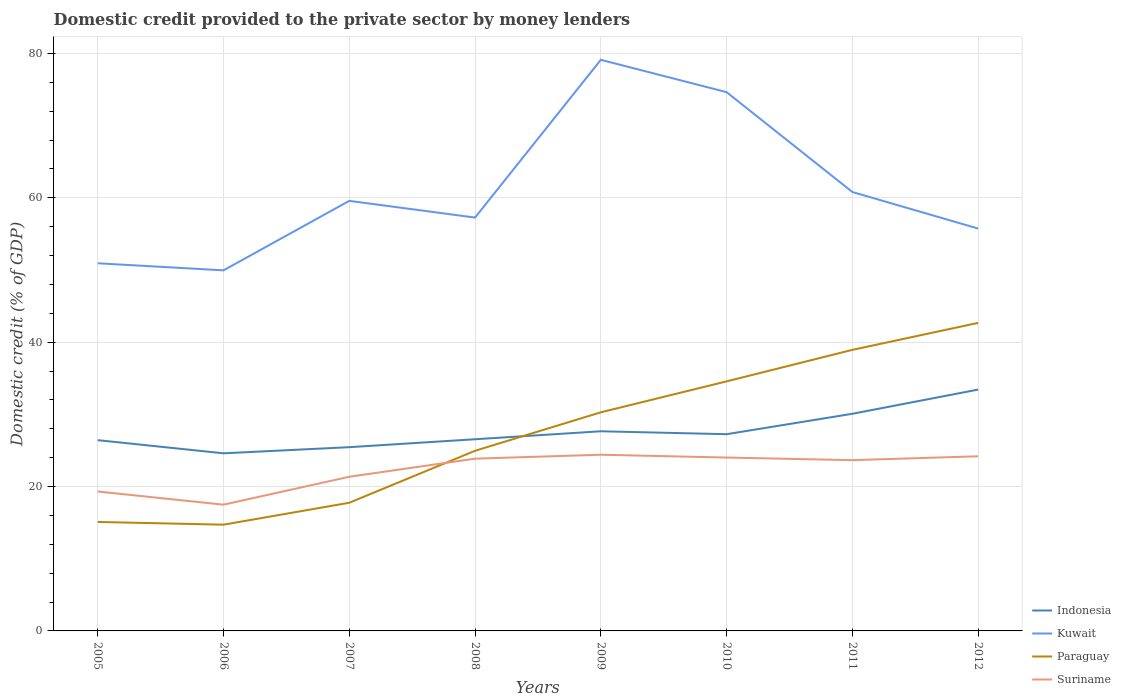How many different coloured lines are there?
Keep it short and to the point. 4. Does the line corresponding to Indonesia intersect with the line corresponding to Paraguay?
Ensure brevity in your answer.  Yes. Is the number of lines equal to the number of legend labels?
Ensure brevity in your answer.  Yes. Across all years, what is the maximum domestic credit provided to the private sector by money lenders in Indonesia?
Your response must be concise. 24.61. In which year was the domestic credit provided to the private sector by money lenders in Paraguay maximum?
Give a very brief answer. 2006. What is the total domestic credit provided to the private sector by money lenders in Suriname in the graph?
Keep it short and to the point. -2.84. What is the difference between the highest and the second highest domestic credit provided to the private sector by money lenders in Paraguay?
Ensure brevity in your answer.  27.96. What is the difference between the highest and the lowest domestic credit provided to the private sector by money lenders in Paraguay?
Your answer should be very brief. 4. Is the domestic credit provided to the private sector by money lenders in Kuwait strictly greater than the domestic credit provided to the private sector by money lenders in Paraguay over the years?
Provide a short and direct response. No. How many lines are there?
Make the answer very short. 4. Does the graph contain any zero values?
Your answer should be compact. No. How many legend labels are there?
Your answer should be compact. 4. What is the title of the graph?
Keep it short and to the point. Domestic credit provided to the private sector by money lenders. What is the label or title of the Y-axis?
Provide a succinct answer. Domestic credit (% of GDP). What is the Domestic credit (% of GDP) of Indonesia in 2005?
Your answer should be very brief. 26.43. What is the Domestic credit (% of GDP) of Kuwait in 2005?
Your answer should be very brief. 50.93. What is the Domestic credit (% of GDP) in Paraguay in 2005?
Make the answer very short. 15.1. What is the Domestic credit (% of GDP) of Suriname in 2005?
Provide a succinct answer. 19.32. What is the Domestic credit (% of GDP) in Indonesia in 2006?
Your answer should be very brief. 24.61. What is the Domestic credit (% of GDP) of Kuwait in 2006?
Ensure brevity in your answer.  49.95. What is the Domestic credit (% of GDP) of Paraguay in 2006?
Your answer should be compact. 14.72. What is the Domestic credit (% of GDP) of Suriname in 2006?
Your answer should be compact. 17.49. What is the Domestic credit (% of GDP) in Indonesia in 2007?
Your answer should be very brief. 25.46. What is the Domestic credit (% of GDP) of Kuwait in 2007?
Give a very brief answer. 59.58. What is the Domestic credit (% of GDP) of Paraguay in 2007?
Offer a very short reply. 17.76. What is the Domestic credit (% of GDP) in Suriname in 2007?
Make the answer very short. 21.36. What is the Domestic credit (% of GDP) of Indonesia in 2008?
Your answer should be compact. 26.55. What is the Domestic credit (% of GDP) in Kuwait in 2008?
Your response must be concise. 57.26. What is the Domestic credit (% of GDP) of Paraguay in 2008?
Make the answer very short. 24.96. What is the Domestic credit (% of GDP) in Suriname in 2008?
Your answer should be very brief. 23.86. What is the Domestic credit (% of GDP) in Indonesia in 2009?
Give a very brief answer. 27.66. What is the Domestic credit (% of GDP) of Kuwait in 2009?
Give a very brief answer. 79.12. What is the Domestic credit (% of GDP) of Paraguay in 2009?
Provide a short and direct response. 30.29. What is the Domestic credit (% of GDP) of Suriname in 2009?
Give a very brief answer. 24.41. What is the Domestic credit (% of GDP) of Indonesia in 2010?
Provide a succinct answer. 27.25. What is the Domestic credit (% of GDP) in Kuwait in 2010?
Offer a terse response. 74.64. What is the Domestic credit (% of GDP) in Paraguay in 2010?
Keep it short and to the point. 34.57. What is the Domestic credit (% of GDP) of Suriname in 2010?
Give a very brief answer. 24.02. What is the Domestic credit (% of GDP) of Indonesia in 2011?
Provide a succinct answer. 30.08. What is the Domestic credit (% of GDP) of Kuwait in 2011?
Provide a succinct answer. 60.81. What is the Domestic credit (% of GDP) of Paraguay in 2011?
Keep it short and to the point. 38.94. What is the Domestic credit (% of GDP) in Suriname in 2011?
Provide a short and direct response. 23.66. What is the Domestic credit (% of GDP) in Indonesia in 2012?
Your response must be concise. 33.43. What is the Domestic credit (% of GDP) of Kuwait in 2012?
Give a very brief answer. 55.74. What is the Domestic credit (% of GDP) in Paraguay in 2012?
Your answer should be compact. 42.68. What is the Domestic credit (% of GDP) of Suriname in 2012?
Offer a terse response. 24.19. Across all years, what is the maximum Domestic credit (% of GDP) in Indonesia?
Your response must be concise. 33.43. Across all years, what is the maximum Domestic credit (% of GDP) in Kuwait?
Provide a short and direct response. 79.12. Across all years, what is the maximum Domestic credit (% of GDP) of Paraguay?
Your response must be concise. 42.68. Across all years, what is the maximum Domestic credit (% of GDP) of Suriname?
Provide a succinct answer. 24.41. Across all years, what is the minimum Domestic credit (% of GDP) of Indonesia?
Your response must be concise. 24.61. Across all years, what is the minimum Domestic credit (% of GDP) in Kuwait?
Your response must be concise. 49.95. Across all years, what is the minimum Domestic credit (% of GDP) of Paraguay?
Provide a succinct answer. 14.72. Across all years, what is the minimum Domestic credit (% of GDP) of Suriname?
Offer a very short reply. 17.49. What is the total Domestic credit (% of GDP) of Indonesia in the graph?
Give a very brief answer. 221.47. What is the total Domestic credit (% of GDP) in Kuwait in the graph?
Your answer should be compact. 488.04. What is the total Domestic credit (% of GDP) in Paraguay in the graph?
Provide a short and direct response. 219. What is the total Domestic credit (% of GDP) in Suriname in the graph?
Ensure brevity in your answer.  178.31. What is the difference between the Domestic credit (% of GDP) in Indonesia in 2005 and that in 2006?
Your answer should be very brief. 1.82. What is the difference between the Domestic credit (% of GDP) in Kuwait in 2005 and that in 2006?
Offer a terse response. 0.98. What is the difference between the Domestic credit (% of GDP) in Paraguay in 2005 and that in 2006?
Your answer should be very brief. 0.38. What is the difference between the Domestic credit (% of GDP) of Suriname in 2005 and that in 2006?
Provide a succinct answer. 1.83. What is the difference between the Domestic credit (% of GDP) of Indonesia in 2005 and that in 2007?
Offer a very short reply. 0.97. What is the difference between the Domestic credit (% of GDP) of Kuwait in 2005 and that in 2007?
Provide a succinct answer. -8.65. What is the difference between the Domestic credit (% of GDP) in Paraguay in 2005 and that in 2007?
Make the answer very short. -2.66. What is the difference between the Domestic credit (% of GDP) of Suriname in 2005 and that in 2007?
Give a very brief answer. -2.04. What is the difference between the Domestic credit (% of GDP) in Indonesia in 2005 and that in 2008?
Keep it short and to the point. -0.13. What is the difference between the Domestic credit (% of GDP) of Kuwait in 2005 and that in 2008?
Give a very brief answer. -6.33. What is the difference between the Domestic credit (% of GDP) of Paraguay in 2005 and that in 2008?
Provide a succinct answer. -9.86. What is the difference between the Domestic credit (% of GDP) of Suriname in 2005 and that in 2008?
Provide a succinct answer. -4.55. What is the difference between the Domestic credit (% of GDP) of Indonesia in 2005 and that in 2009?
Your answer should be very brief. -1.23. What is the difference between the Domestic credit (% of GDP) of Kuwait in 2005 and that in 2009?
Provide a succinct answer. -28.19. What is the difference between the Domestic credit (% of GDP) in Paraguay in 2005 and that in 2009?
Your answer should be compact. -15.19. What is the difference between the Domestic credit (% of GDP) of Suriname in 2005 and that in 2009?
Offer a terse response. -5.09. What is the difference between the Domestic credit (% of GDP) in Indonesia in 2005 and that in 2010?
Give a very brief answer. -0.83. What is the difference between the Domestic credit (% of GDP) in Kuwait in 2005 and that in 2010?
Provide a succinct answer. -23.71. What is the difference between the Domestic credit (% of GDP) of Paraguay in 2005 and that in 2010?
Your answer should be very brief. -19.48. What is the difference between the Domestic credit (% of GDP) of Suriname in 2005 and that in 2010?
Offer a very short reply. -4.7. What is the difference between the Domestic credit (% of GDP) in Indonesia in 2005 and that in 2011?
Make the answer very short. -3.65. What is the difference between the Domestic credit (% of GDP) in Kuwait in 2005 and that in 2011?
Your response must be concise. -9.87. What is the difference between the Domestic credit (% of GDP) of Paraguay in 2005 and that in 2011?
Your answer should be compact. -23.84. What is the difference between the Domestic credit (% of GDP) of Suriname in 2005 and that in 2011?
Offer a terse response. -4.34. What is the difference between the Domestic credit (% of GDP) of Indonesia in 2005 and that in 2012?
Offer a very short reply. -7.01. What is the difference between the Domestic credit (% of GDP) in Kuwait in 2005 and that in 2012?
Give a very brief answer. -4.81. What is the difference between the Domestic credit (% of GDP) in Paraguay in 2005 and that in 2012?
Provide a succinct answer. -27.58. What is the difference between the Domestic credit (% of GDP) of Suriname in 2005 and that in 2012?
Keep it short and to the point. -4.88. What is the difference between the Domestic credit (% of GDP) of Indonesia in 2006 and that in 2007?
Ensure brevity in your answer.  -0.85. What is the difference between the Domestic credit (% of GDP) in Kuwait in 2006 and that in 2007?
Make the answer very short. -9.63. What is the difference between the Domestic credit (% of GDP) in Paraguay in 2006 and that in 2007?
Make the answer very short. -3.04. What is the difference between the Domestic credit (% of GDP) of Suriname in 2006 and that in 2007?
Provide a succinct answer. -3.87. What is the difference between the Domestic credit (% of GDP) in Indonesia in 2006 and that in 2008?
Keep it short and to the point. -1.95. What is the difference between the Domestic credit (% of GDP) in Kuwait in 2006 and that in 2008?
Offer a terse response. -7.31. What is the difference between the Domestic credit (% of GDP) of Paraguay in 2006 and that in 2008?
Keep it short and to the point. -10.24. What is the difference between the Domestic credit (% of GDP) of Suriname in 2006 and that in 2008?
Ensure brevity in your answer.  -6.38. What is the difference between the Domestic credit (% of GDP) of Indonesia in 2006 and that in 2009?
Ensure brevity in your answer.  -3.05. What is the difference between the Domestic credit (% of GDP) in Kuwait in 2006 and that in 2009?
Your answer should be compact. -29.17. What is the difference between the Domestic credit (% of GDP) of Paraguay in 2006 and that in 2009?
Your response must be concise. -15.57. What is the difference between the Domestic credit (% of GDP) of Suriname in 2006 and that in 2009?
Make the answer very short. -6.92. What is the difference between the Domestic credit (% of GDP) in Indonesia in 2006 and that in 2010?
Your answer should be compact. -2.65. What is the difference between the Domestic credit (% of GDP) of Kuwait in 2006 and that in 2010?
Ensure brevity in your answer.  -24.69. What is the difference between the Domestic credit (% of GDP) of Paraguay in 2006 and that in 2010?
Keep it short and to the point. -19.85. What is the difference between the Domestic credit (% of GDP) of Suriname in 2006 and that in 2010?
Give a very brief answer. -6.53. What is the difference between the Domestic credit (% of GDP) in Indonesia in 2006 and that in 2011?
Ensure brevity in your answer.  -5.48. What is the difference between the Domestic credit (% of GDP) of Kuwait in 2006 and that in 2011?
Your response must be concise. -10.85. What is the difference between the Domestic credit (% of GDP) of Paraguay in 2006 and that in 2011?
Your response must be concise. -24.22. What is the difference between the Domestic credit (% of GDP) of Suriname in 2006 and that in 2011?
Provide a succinct answer. -6.17. What is the difference between the Domestic credit (% of GDP) in Indonesia in 2006 and that in 2012?
Provide a short and direct response. -8.83. What is the difference between the Domestic credit (% of GDP) of Kuwait in 2006 and that in 2012?
Offer a very short reply. -5.79. What is the difference between the Domestic credit (% of GDP) in Paraguay in 2006 and that in 2012?
Ensure brevity in your answer.  -27.96. What is the difference between the Domestic credit (% of GDP) of Suriname in 2006 and that in 2012?
Provide a short and direct response. -6.71. What is the difference between the Domestic credit (% of GDP) in Indonesia in 2007 and that in 2008?
Offer a terse response. -1.1. What is the difference between the Domestic credit (% of GDP) in Kuwait in 2007 and that in 2008?
Provide a short and direct response. 2.31. What is the difference between the Domestic credit (% of GDP) in Paraguay in 2007 and that in 2008?
Your response must be concise. -7.2. What is the difference between the Domestic credit (% of GDP) of Suriname in 2007 and that in 2008?
Make the answer very short. -2.51. What is the difference between the Domestic credit (% of GDP) of Indonesia in 2007 and that in 2009?
Make the answer very short. -2.2. What is the difference between the Domestic credit (% of GDP) of Kuwait in 2007 and that in 2009?
Your answer should be compact. -19.54. What is the difference between the Domestic credit (% of GDP) of Paraguay in 2007 and that in 2009?
Offer a very short reply. -12.53. What is the difference between the Domestic credit (% of GDP) of Suriname in 2007 and that in 2009?
Your answer should be compact. -3.05. What is the difference between the Domestic credit (% of GDP) of Indonesia in 2007 and that in 2010?
Give a very brief answer. -1.8. What is the difference between the Domestic credit (% of GDP) of Kuwait in 2007 and that in 2010?
Offer a terse response. -15.06. What is the difference between the Domestic credit (% of GDP) of Paraguay in 2007 and that in 2010?
Your answer should be compact. -16.82. What is the difference between the Domestic credit (% of GDP) of Suriname in 2007 and that in 2010?
Provide a short and direct response. -2.66. What is the difference between the Domestic credit (% of GDP) in Indonesia in 2007 and that in 2011?
Give a very brief answer. -4.63. What is the difference between the Domestic credit (% of GDP) in Kuwait in 2007 and that in 2011?
Your response must be concise. -1.23. What is the difference between the Domestic credit (% of GDP) in Paraguay in 2007 and that in 2011?
Give a very brief answer. -21.18. What is the difference between the Domestic credit (% of GDP) in Suriname in 2007 and that in 2011?
Offer a terse response. -2.3. What is the difference between the Domestic credit (% of GDP) of Indonesia in 2007 and that in 2012?
Keep it short and to the point. -7.98. What is the difference between the Domestic credit (% of GDP) in Kuwait in 2007 and that in 2012?
Your response must be concise. 3.84. What is the difference between the Domestic credit (% of GDP) in Paraguay in 2007 and that in 2012?
Give a very brief answer. -24.92. What is the difference between the Domestic credit (% of GDP) in Suriname in 2007 and that in 2012?
Make the answer very short. -2.84. What is the difference between the Domestic credit (% of GDP) in Indonesia in 2008 and that in 2009?
Give a very brief answer. -1.11. What is the difference between the Domestic credit (% of GDP) of Kuwait in 2008 and that in 2009?
Give a very brief answer. -21.85. What is the difference between the Domestic credit (% of GDP) in Paraguay in 2008 and that in 2009?
Your response must be concise. -5.33. What is the difference between the Domestic credit (% of GDP) of Suriname in 2008 and that in 2009?
Offer a terse response. -0.54. What is the difference between the Domestic credit (% of GDP) of Indonesia in 2008 and that in 2010?
Provide a short and direct response. -0.7. What is the difference between the Domestic credit (% of GDP) in Kuwait in 2008 and that in 2010?
Your answer should be very brief. -17.37. What is the difference between the Domestic credit (% of GDP) of Paraguay in 2008 and that in 2010?
Your answer should be very brief. -9.62. What is the difference between the Domestic credit (% of GDP) of Suriname in 2008 and that in 2010?
Your response must be concise. -0.15. What is the difference between the Domestic credit (% of GDP) in Indonesia in 2008 and that in 2011?
Your answer should be very brief. -3.53. What is the difference between the Domestic credit (% of GDP) in Kuwait in 2008 and that in 2011?
Offer a terse response. -3.54. What is the difference between the Domestic credit (% of GDP) of Paraguay in 2008 and that in 2011?
Your answer should be compact. -13.98. What is the difference between the Domestic credit (% of GDP) in Suriname in 2008 and that in 2011?
Give a very brief answer. 0.21. What is the difference between the Domestic credit (% of GDP) of Indonesia in 2008 and that in 2012?
Your response must be concise. -6.88. What is the difference between the Domestic credit (% of GDP) in Kuwait in 2008 and that in 2012?
Keep it short and to the point. 1.52. What is the difference between the Domestic credit (% of GDP) of Paraguay in 2008 and that in 2012?
Your response must be concise. -17.72. What is the difference between the Domestic credit (% of GDP) in Suriname in 2008 and that in 2012?
Your response must be concise. -0.33. What is the difference between the Domestic credit (% of GDP) in Indonesia in 2009 and that in 2010?
Your answer should be compact. 0.41. What is the difference between the Domestic credit (% of GDP) of Kuwait in 2009 and that in 2010?
Your response must be concise. 4.48. What is the difference between the Domestic credit (% of GDP) in Paraguay in 2009 and that in 2010?
Your answer should be very brief. -4.29. What is the difference between the Domestic credit (% of GDP) of Suriname in 2009 and that in 2010?
Give a very brief answer. 0.39. What is the difference between the Domestic credit (% of GDP) in Indonesia in 2009 and that in 2011?
Your answer should be very brief. -2.42. What is the difference between the Domestic credit (% of GDP) in Kuwait in 2009 and that in 2011?
Offer a very short reply. 18.31. What is the difference between the Domestic credit (% of GDP) in Paraguay in 2009 and that in 2011?
Keep it short and to the point. -8.65. What is the difference between the Domestic credit (% of GDP) in Suriname in 2009 and that in 2011?
Provide a short and direct response. 0.75. What is the difference between the Domestic credit (% of GDP) in Indonesia in 2009 and that in 2012?
Offer a very short reply. -5.78. What is the difference between the Domestic credit (% of GDP) in Kuwait in 2009 and that in 2012?
Provide a short and direct response. 23.38. What is the difference between the Domestic credit (% of GDP) in Paraguay in 2009 and that in 2012?
Your response must be concise. -12.39. What is the difference between the Domestic credit (% of GDP) in Suriname in 2009 and that in 2012?
Provide a short and direct response. 0.21. What is the difference between the Domestic credit (% of GDP) of Indonesia in 2010 and that in 2011?
Provide a succinct answer. -2.83. What is the difference between the Domestic credit (% of GDP) in Kuwait in 2010 and that in 2011?
Provide a succinct answer. 13.83. What is the difference between the Domestic credit (% of GDP) of Paraguay in 2010 and that in 2011?
Offer a terse response. -4.37. What is the difference between the Domestic credit (% of GDP) in Suriname in 2010 and that in 2011?
Offer a terse response. 0.36. What is the difference between the Domestic credit (% of GDP) of Indonesia in 2010 and that in 2012?
Offer a terse response. -6.18. What is the difference between the Domestic credit (% of GDP) of Kuwait in 2010 and that in 2012?
Your answer should be very brief. 18.9. What is the difference between the Domestic credit (% of GDP) of Paraguay in 2010 and that in 2012?
Offer a very short reply. -8.1. What is the difference between the Domestic credit (% of GDP) of Suriname in 2010 and that in 2012?
Keep it short and to the point. -0.18. What is the difference between the Domestic credit (% of GDP) in Indonesia in 2011 and that in 2012?
Provide a short and direct response. -3.35. What is the difference between the Domestic credit (% of GDP) of Kuwait in 2011 and that in 2012?
Provide a short and direct response. 5.06. What is the difference between the Domestic credit (% of GDP) in Paraguay in 2011 and that in 2012?
Your response must be concise. -3.74. What is the difference between the Domestic credit (% of GDP) of Suriname in 2011 and that in 2012?
Ensure brevity in your answer.  -0.54. What is the difference between the Domestic credit (% of GDP) in Indonesia in 2005 and the Domestic credit (% of GDP) in Kuwait in 2006?
Your response must be concise. -23.53. What is the difference between the Domestic credit (% of GDP) of Indonesia in 2005 and the Domestic credit (% of GDP) of Paraguay in 2006?
Keep it short and to the point. 11.71. What is the difference between the Domestic credit (% of GDP) in Indonesia in 2005 and the Domestic credit (% of GDP) in Suriname in 2006?
Your response must be concise. 8.94. What is the difference between the Domestic credit (% of GDP) of Kuwait in 2005 and the Domestic credit (% of GDP) of Paraguay in 2006?
Your answer should be very brief. 36.21. What is the difference between the Domestic credit (% of GDP) in Kuwait in 2005 and the Domestic credit (% of GDP) in Suriname in 2006?
Give a very brief answer. 33.44. What is the difference between the Domestic credit (% of GDP) in Paraguay in 2005 and the Domestic credit (% of GDP) in Suriname in 2006?
Provide a short and direct response. -2.39. What is the difference between the Domestic credit (% of GDP) in Indonesia in 2005 and the Domestic credit (% of GDP) in Kuwait in 2007?
Your answer should be very brief. -33.15. What is the difference between the Domestic credit (% of GDP) in Indonesia in 2005 and the Domestic credit (% of GDP) in Paraguay in 2007?
Your response must be concise. 8.67. What is the difference between the Domestic credit (% of GDP) in Indonesia in 2005 and the Domestic credit (% of GDP) in Suriname in 2007?
Keep it short and to the point. 5.07. What is the difference between the Domestic credit (% of GDP) of Kuwait in 2005 and the Domestic credit (% of GDP) of Paraguay in 2007?
Offer a very short reply. 33.18. What is the difference between the Domestic credit (% of GDP) of Kuwait in 2005 and the Domestic credit (% of GDP) of Suriname in 2007?
Give a very brief answer. 29.57. What is the difference between the Domestic credit (% of GDP) in Paraguay in 2005 and the Domestic credit (% of GDP) in Suriname in 2007?
Keep it short and to the point. -6.26. What is the difference between the Domestic credit (% of GDP) of Indonesia in 2005 and the Domestic credit (% of GDP) of Kuwait in 2008?
Your answer should be very brief. -30.84. What is the difference between the Domestic credit (% of GDP) in Indonesia in 2005 and the Domestic credit (% of GDP) in Paraguay in 2008?
Offer a very short reply. 1.47. What is the difference between the Domestic credit (% of GDP) of Indonesia in 2005 and the Domestic credit (% of GDP) of Suriname in 2008?
Make the answer very short. 2.56. What is the difference between the Domestic credit (% of GDP) in Kuwait in 2005 and the Domestic credit (% of GDP) in Paraguay in 2008?
Provide a succinct answer. 25.98. What is the difference between the Domestic credit (% of GDP) in Kuwait in 2005 and the Domestic credit (% of GDP) in Suriname in 2008?
Ensure brevity in your answer.  27.07. What is the difference between the Domestic credit (% of GDP) in Paraguay in 2005 and the Domestic credit (% of GDP) in Suriname in 2008?
Your answer should be very brief. -8.77. What is the difference between the Domestic credit (% of GDP) of Indonesia in 2005 and the Domestic credit (% of GDP) of Kuwait in 2009?
Offer a terse response. -52.69. What is the difference between the Domestic credit (% of GDP) of Indonesia in 2005 and the Domestic credit (% of GDP) of Paraguay in 2009?
Your answer should be compact. -3.86. What is the difference between the Domestic credit (% of GDP) of Indonesia in 2005 and the Domestic credit (% of GDP) of Suriname in 2009?
Provide a short and direct response. 2.02. What is the difference between the Domestic credit (% of GDP) of Kuwait in 2005 and the Domestic credit (% of GDP) of Paraguay in 2009?
Give a very brief answer. 20.65. What is the difference between the Domestic credit (% of GDP) in Kuwait in 2005 and the Domestic credit (% of GDP) in Suriname in 2009?
Your answer should be very brief. 26.53. What is the difference between the Domestic credit (% of GDP) in Paraguay in 2005 and the Domestic credit (% of GDP) in Suriname in 2009?
Ensure brevity in your answer.  -9.31. What is the difference between the Domestic credit (% of GDP) of Indonesia in 2005 and the Domestic credit (% of GDP) of Kuwait in 2010?
Ensure brevity in your answer.  -48.21. What is the difference between the Domestic credit (% of GDP) of Indonesia in 2005 and the Domestic credit (% of GDP) of Paraguay in 2010?
Make the answer very short. -8.14. What is the difference between the Domestic credit (% of GDP) in Indonesia in 2005 and the Domestic credit (% of GDP) in Suriname in 2010?
Keep it short and to the point. 2.41. What is the difference between the Domestic credit (% of GDP) of Kuwait in 2005 and the Domestic credit (% of GDP) of Paraguay in 2010?
Keep it short and to the point. 16.36. What is the difference between the Domestic credit (% of GDP) in Kuwait in 2005 and the Domestic credit (% of GDP) in Suriname in 2010?
Provide a succinct answer. 26.91. What is the difference between the Domestic credit (% of GDP) in Paraguay in 2005 and the Domestic credit (% of GDP) in Suriname in 2010?
Offer a terse response. -8.92. What is the difference between the Domestic credit (% of GDP) of Indonesia in 2005 and the Domestic credit (% of GDP) of Kuwait in 2011?
Give a very brief answer. -34.38. What is the difference between the Domestic credit (% of GDP) in Indonesia in 2005 and the Domestic credit (% of GDP) in Paraguay in 2011?
Make the answer very short. -12.51. What is the difference between the Domestic credit (% of GDP) of Indonesia in 2005 and the Domestic credit (% of GDP) of Suriname in 2011?
Offer a very short reply. 2.77. What is the difference between the Domestic credit (% of GDP) of Kuwait in 2005 and the Domestic credit (% of GDP) of Paraguay in 2011?
Ensure brevity in your answer.  12. What is the difference between the Domestic credit (% of GDP) of Kuwait in 2005 and the Domestic credit (% of GDP) of Suriname in 2011?
Offer a terse response. 27.28. What is the difference between the Domestic credit (% of GDP) of Paraguay in 2005 and the Domestic credit (% of GDP) of Suriname in 2011?
Offer a very short reply. -8.56. What is the difference between the Domestic credit (% of GDP) of Indonesia in 2005 and the Domestic credit (% of GDP) of Kuwait in 2012?
Keep it short and to the point. -29.32. What is the difference between the Domestic credit (% of GDP) in Indonesia in 2005 and the Domestic credit (% of GDP) in Paraguay in 2012?
Your response must be concise. -16.25. What is the difference between the Domestic credit (% of GDP) of Indonesia in 2005 and the Domestic credit (% of GDP) of Suriname in 2012?
Provide a succinct answer. 2.23. What is the difference between the Domestic credit (% of GDP) of Kuwait in 2005 and the Domestic credit (% of GDP) of Paraguay in 2012?
Give a very brief answer. 8.26. What is the difference between the Domestic credit (% of GDP) in Kuwait in 2005 and the Domestic credit (% of GDP) in Suriname in 2012?
Ensure brevity in your answer.  26.74. What is the difference between the Domestic credit (% of GDP) of Paraguay in 2005 and the Domestic credit (% of GDP) of Suriname in 2012?
Offer a terse response. -9.1. What is the difference between the Domestic credit (% of GDP) of Indonesia in 2006 and the Domestic credit (% of GDP) of Kuwait in 2007?
Make the answer very short. -34.97. What is the difference between the Domestic credit (% of GDP) in Indonesia in 2006 and the Domestic credit (% of GDP) in Paraguay in 2007?
Make the answer very short. 6.85. What is the difference between the Domestic credit (% of GDP) in Indonesia in 2006 and the Domestic credit (% of GDP) in Suriname in 2007?
Offer a very short reply. 3.25. What is the difference between the Domestic credit (% of GDP) of Kuwait in 2006 and the Domestic credit (% of GDP) of Paraguay in 2007?
Your answer should be compact. 32.2. What is the difference between the Domestic credit (% of GDP) in Kuwait in 2006 and the Domestic credit (% of GDP) in Suriname in 2007?
Ensure brevity in your answer.  28.59. What is the difference between the Domestic credit (% of GDP) in Paraguay in 2006 and the Domestic credit (% of GDP) in Suriname in 2007?
Your response must be concise. -6.64. What is the difference between the Domestic credit (% of GDP) of Indonesia in 2006 and the Domestic credit (% of GDP) of Kuwait in 2008?
Your response must be concise. -32.66. What is the difference between the Domestic credit (% of GDP) of Indonesia in 2006 and the Domestic credit (% of GDP) of Paraguay in 2008?
Provide a succinct answer. -0.35. What is the difference between the Domestic credit (% of GDP) in Indonesia in 2006 and the Domestic credit (% of GDP) in Suriname in 2008?
Make the answer very short. 0.74. What is the difference between the Domestic credit (% of GDP) in Kuwait in 2006 and the Domestic credit (% of GDP) in Paraguay in 2008?
Your answer should be compact. 25. What is the difference between the Domestic credit (% of GDP) in Kuwait in 2006 and the Domestic credit (% of GDP) in Suriname in 2008?
Provide a succinct answer. 26.09. What is the difference between the Domestic credit (% of GDP) of Paraguay in 2006 and the Domestic credit (% of GDP) of Suriname in 2008?
Your answer should be compact. -9.15. What is the difference between the Domestic credit (% of GDP) of Indonesia in 2006 and the Domestic credit (% of GDP) of Kuwait in 2009?
Offer a very short reply. -54.51. What is the difference between the Domestic credit (% of GDP) in Indonesia in 2006 and the Domestic credit (% of GDP) in Paraguay in 2009?
Keep it short and to the point. -5.68. What is the difference between the Domestic credit (% of GDP) in Indonesia in 2006 and the Domestic credit (% of GDP) in Suriname in 2009?
Provide a succinct answer. 0.2. What is the difference between the Domestic credit (% of GDP) of Kuwait in 2006 and the Domestic credit (% of GDP) of Paraguay in 2009?
Your response must be concise. 19.67. What is the difference between the Domestic credit (% of GDP) of Kuwait in 2006 and the Domestic credit (% of GDP) of Suriname in 2009?
Keep it short and to the point. 25.55. What is the difference between the Domestic credit (% of GDP) of Paraguay in 2006 and the Domestic credit (% of GDP) of Suriname in 2009?
Provide a succinct answer. -9.69. What is the difference between the Domestic credit (% of GDP) in Indonesia in 2006 and the Domestic credit (% of GDP) in Kuwait in 2010?
Your answer should be compact. -50.03. What is the difference between the Domestic credit (% of GDP) of Indonesia in 2006 and the Domestic credit (% of GDP) of Paraguay in 2010?
Give a very brief answer. -9.97. What is the difference between the Domestic credit (% of GDP) in Indonesia in 2006 and the Domestic credit (% of GDP) in Suriname in 2010?
Provide a short and direct response. 0.59. What is the difference between the Domestic credit (% of GDP) of Kuwait in 2006 and the Domestic credit (% of GDP) of Paraguay in 2010?
Provide a succinct answer. 15.38. What is the difference between the Domestic credit (% of GDP) in Kuwait in 2006 and the Domestic credit (% of GDP) in Suriname in 2010?
Offer a very short reply. 25.93. What is the difference between the Domestic credit (% of GDP) in Paraguay in 2006 and the Domestic credit (% of GDP) in Suriname in 2010?
Make the answer very short. -9.3. What is the difference between the Domestic credit (% of GDP) in Indonesia in 2006 and the Domestic credit (% of GDP) in Kuwait in 2011?
Offer a terse response. -36.2. What is the difference between the Domestic credit (% of GDP) of Indonesia in 2006 and the Domestic credit (% of GDP) of Paraguay in 2011?
Ensure brevity in your answer.  -14.33. What is the difference between the Domestic credit (% of GDP) in Indonesia in 2006 and the Domestic credit (% of GDP) in Suriname in 2011?
Your response must be concise. 0.95. What is the difference between the Domestic credit (% of GDP) in Kuwait in 2006 and the Domestic credit (% of GDP) in Paraguay in 2011?
Provide a succinct answer. 11.02. What is the difference between the Domestic credit (% of GDP) of Kuwait in 2006 and the Domestic credit (% of GDP) of Suriname in 2011?
Offer a terse response. 26.3. What is the difference between the Domestic credit (% of GDP) in Paraguay in 2006 and the Domestic credit (% of GDP) in Suriname in 2011?
Provide a succinct answer. -8.94. What is the difference between the Domestic credit (% of GDP) in Indonesia in 2006 and the Domestic credit (% of GDP) in Kuwait in 2012?
Ensure brevity in your answer.  -31.14. What is the difference between the Domestic credit (% of GDP) in Indonesia in 2006 and the Domestic credit (% of GDP) in Paraguay in 2012?
Your answer should be compact. -18.07. What is the difference between the Domestic credit (% of GDP) in Indonesia in 2006 and the Domestic credit (% of GDP) in Suriname in 2012?
Your response must be concise. 0.41. What is the difference between the Domestic credit (% of GDP) of Kuwait in 2006 and the Domestic credit (% of GDP) of Paraguay in 2012?
Provide a short and direct response. 7.28. What is the difference between the Domestic credit (% of GDP) in Kuwait in 2006 and the Domestic credit (% of GDP) in Suriname in 2012?
Your answer should be very brief. 25.76. What is the difference between the Domestic credit (% of GDP) in Paraguay in 2006 and the Domestic credit (% of GDP) in Suriname in 2012?
Your response must be concise. -9.48. What is the difference between the Domestic credit (% of GDP) in Indonesia in 2007 and the Domestic credit (% of GDP) in Kuwait in 2008?
Ensure brevity in your answer.  -31.81. What is the difference between the Domestic credit (% of GDP) in Indonesia in 2007 and the Domestic credit (% of GDP) in Paraguay in 2008?
Offer a terse response. 0.5. What is the difference between the Domestic credit (% of GDP) of Indonesia in 2007 and the Domestic credit (% of GDP) of Suriname in 2008?
Give a very brief answer. 1.59. What is the difference between the Domestic credit (% of GDP) in Kuwait in 2007 and the Domestic credit (% of GDP) in Paraguay in 2008?
Provide a short and direct response. 34.62. What is the difference between the Domestic credit (% of GDP) of Kuwait in 2007 and the Domestic credit (% of GDP) of Suriname in 2008?
Provide a succinct answer. 35.71. What is the difference between the Domestic credit (% of GDP) of Paraguay in 2007 and the Domestic credit (% of GDP) of Suriname in 2008?
Provide a succinct answer. -6.11. What is the difference between the Domestic credit (% of GDP) in Indonesia in 2007 and the Domestic credit (% of GDP) in Kuwait in 2009?
Your answer should be compact. -53.66. What is the difference between the Domestic credit (% of GDP) in Indonesia in 2007 and the Domestic credit (% of GDP) in Paraguay in 2009?
Provide a succinct answer. -4.83. What is the difference between the Domestic credit (% of GDP) in Indonesia in 2007 and the Domestic credit (% of GDP) in Suriname in 2009?
Ensure brevity in your answer.  1.05. What is the difference between the Domestic credit (% of GDP) of Kuwait in 2007 and the Domestic credit (% of GDP) of Paraguay in 2009?
Give a very brief answer. 29.29. What is the difference between the Domestic credit (% of GDP) of Kuwait in 2007 and the Domestic credit (% of GDP) of Suriname in 2009?
Offer a terse response. 35.17. What is the difference between the Domestic credit (% of GDP) in Paraguay in 2007 and the Domestic credit (% of GDP) in Suriname in 2009?
Offer a very short reply. -6.65. What is the difference between the Domestic credit (% of GDP) in Indonesia in 2007 and the Domestic credit (% of GDP) in Kuwait in 2010?
Provide a succinct answer. -49.18. What is the difference between the Domestic credit (% of GDP) of Indonesia in 2007 and the Domestic credit (% of GDP) of Paraguay in 2010?
Ensure brevity in your answer.  -9.12. What is the difference between the Domestic credit (% of GDP) in Indonesia in 2007 and the Domestic credit (% of GDP) in Suriname in 2010?
Your answer should be very brief. 1.44. What is the difference between the Domestic credit (% of GDP) of Kuwait in 2007 and the Domestic credit (% of GDP) of Paraguay in 2010?
Ensure brevity in your answer.  25.01. What is the difference between the Domestic credit (% of GDP) in Kuwait in 2007 and the Domestic credit (% of GDP) in Suriname in 2010?
Keep it short and to the point. 35.56. What is the difference between the Domestic credit (% of GDP) of Paraguay in 2007 and the Domestic credit (% of GDP) of Suriname in 2010?
Ensure brevity in your answer.  -6.26. What is the difference between the Domestic credit (% of GDP) in Indonesia in 2007 and the Domestic credit (% of GDP) in Kuwait in 2011?
Keep it short and to the point. -35.35. What is the difference between the Domestic credit (% of GDP) in Indonesia in 2007 and the Domestic credit (% of GDP) in Paraguay in 2011?
Provide a short and direct response. -13.48. What is the difference between the Domestic credit (% of GDP) of Indonesia in 2007 and the Domestic credit (% of GDP) of Suriname in 2011?
Give a very brief answer. 1.8. What is the difference between the Domestic credit (% of GDP) in Kuwait in 2007 and the Domestic credit (% of GDP) in Paraguay in 2011?
Make the answer very short. 20.64. What is the difference between the Domestic credit (% of GDP) in Kuwait in 2007 and the Domestic credit (% of GDP) in Suriname in 2011?
Offer a terse response. 35.92. What is the difference between the Domestic credit (% of GDP) in Paraguay in 2007 and the Domestic credit (% of GDP) in Suriname in 2011?
Provide a short and direct response. -5.9. What is the difference between the Domestic credit (% of GDP) of Indonesia in 2007 and the Domestic credit (% of GDP) of Kuwait in 2012?
Offer a very short reply. -30.29. What is the difference between the Domestic credit (% of GDP) of Indonesia in 2007 and the Domestic credit (% of GDP) of Paraguay in 2012?
Keep it short and to the point. -17.22. What is the difference between the Domestic credit (% of GDP) of Indonesia in 2007 and the Domestic credit (% of GDP) of Suriname in 2012?
Make the answer very short. 1.26. What is the difference between the Domestic credit (% of GDP) of Kuwait in 2007 and the Domestic credit (% of GDP) of Paraguay in 2012?
Give a very brief answer. 16.9. What is the difference between the Domestic credit (% of GDP) in Kuwait in 2007 and the Domestic credit (% of GDP) in Suriname in 2012?
Make the answer very short. 35.38. What is the difference between the Domestic credit (% of GDP) in Paraguay in 2007 and the Domestic credit (% of GDP) in Suriname in 2012?
Provide a succinct answer. -6.44. What is the difference between the Domestic credit (% of GDP) of Indonesia in 2008 and the Domestic credit (% of GDP) of Kuwait in 2009?
Your response must be concise. -52.57. What is the difference between the Domestic credit (% of GDP) of Indonesia in 2008 and the Domestic credit (% of GDP) of Paraguay in 2009?
Your answer should be compact. -3.73. What is the difference between the Domestic credit (% of GDP) of Indonesia in 2008 and the Domestic credit (% of GDP) of Suriname in 2009?
Make the answer very short. 2.15. What is the difference between the Domestic credit (% of GDP) in Kuwait in 2008 and the Domestic credit (% of GDP) in Paraguay in 2009?
Make the answer very short. 26.98. What is the difference between the Domestic credit (% of GDP) in Kuwait in 2008 and the Domestic credit (% of GDP) in Suriname in 2009?
Your answer should be compact. 32.86. What is the difference between the Domestic credit (% of GDP) in Paraguay in 2008 and the Domestic credit (% of GDP) in Suriname in 2009?
Your answer should be very brief. 0.55. What is the difference between the Domestic credit (% of GDP) of Indonesia in 2008 and the Domestic credit (% of GDP) of Kuwait in 2010?
Your response must be concise. -48.09. What is the difference between the Domestic credit (% of GDP) of Indonesia in 2008 and the Domestic credit (% of GDP) of Paraguay in 2010?
Ensure brevity in your answer.  -8.02. What is the difference between the Domestic credit (% of GDP) in Indonesia in 2008 and the Domestic credit (% of GDP) in Suriname in 2010?
Provide a succinct answer. 2.53. What is the difference between the Domestic credit (% of GDP) in Kuwait in 2008 and the Domestic credit (% of GDP) in Paraguay in 2010?
Your answer should be compact. 22.69. What is the difference between the Domestic credit (% of GDP) in Kuwait in 2008 and the Domestic credit (% of GDP) in Suriname in 2010?
Offer a terse response. 33.25. What is the difference between the Domestic credit (% of GDP) of Paraguay in 2008 and the Domestic credit (% of GDP) of Suriname in 2010?
Your response must be concise. 0.94. What is the difference between the Domestic credit (% of GDP) in Indonesia in 2008 and the Domestic credit (% of GDP) in Kuwait in 2011?
Provide a short and direct response. -34.25. What is the difference between the Domestic credit (% of GDP) of Indonesia in 2008 and the Domestic credit (% of GDP) of Paraguay in 2011?
Ensure brevity in your answer.  -12.38. What is the difference between the Domestic credit (% of GDP) of Indonesia in 2008 and the Domestic credit (% of GDP) of Suriname in 2011?
Give a very brief answer. 2.9. What is the difference between the Domestic credit (% of GDP) in Kuwait in 2008 and the Domestic credit (% of GDP) in Paraguay in 2011?
Provide a succinct answer. 18.33. What is the difference between the Domestic credit (% of GDP) in Kuwait in 2008 and the Domestic credit (% of GDP) in Suriname in 2011?
Keep it short and to the point. 33.61. What is the difference between the Domestic credit (% of GDP) in Paraguay in 2008 and the Domestic credit (% of GDP) in Suriname in 2011?
Ensure brevity in your answer.  1.3. What is the difference between the Domestic credit (% of GDP) of Indonesia in 2008 and the Domestic credit (% of GDP) of Kuwait in 2012?
Your answer should be compact. -29.19. What is the difference between the Domestic credit (% of GDP) in Indonesia in 2008 and the Domestic credit (% of GDP) in Paraguay in 2012?
Offer a terse response. -16.12. What is the difference between the Domestic credit (% of GDP) in Indonesia in 2008 and the Domestic credit (% of GDP) in Suriname in 2012?
Your response must be concise. 2.36. What is the difference between the Domestic credit (% of GDP) of Kuwait in 2008 and the Domestic credit (% of GDP) of Paraguay in 2012?
Offer a very short reply. 14.59. What is the difference between the Domestic credit (% of GDP) in Kuwait in 2008 and the Domestic credit (% of GDP) in Suriname in 2012?
Keep it short and to the point. 33.07. What is the difference between the Domestic credit (% of GDP) in Paraguay in 2008 and the Domestic credit (% of GDP) in Suriname in 2012?
Your answer should be very brief. 0.76. What is the difference between the Domestic credit (% of GDP) of Indonesia in 2009 and the Domestic credit (% of GDP) of Kuwait in 2010?
Offer a very short reply. -46.98. What is the difference between the Domestic credit (% of GDP) of Indonesia in 2009 and the Domestic credit (% of GDP) of Paraguay in 2010?
Make the answer very short. -6.91. What is the difference between the Domestic credit (% of GDP) in Indonesia in 2009 and the Domestic credit (% of GDP) in Suriname in 2010?
Your response must be concise. 3.64. What is the difference between the Domestic credit (% of GDP) in Kuwait in 2009 and the Domestic credit (% of GDP) in Paraguay in 2010?
Your answer should be very brief. 44.55. What is the difference between the Domestic credit (% of GDP) in Kuwait in 2009 and the Domestic credit (% of GDP) in Suriname in 2010?
Make the answer very short. 55.1. What is the difference between the Domestic credit (% of GDP) of Paraguay in 2009 and the Domestic credit (% of GDP) of Suriname in 2010?
Your answer should be very brief. 6.27. What is the difference between the Domestic credit (% of GDP) of Indonesia in 2009 and the Domestic credit (% of GDP) of Kuwait in 2011?
Your response must be concise. -33.15. What is the difference between the Domestic credit (% of GDP) of Indonesia in 2009 and the Domestic credit (% of GDP) of Paraguay in 2011?
Your response must be concise. -11.28. What is the difference between the Domestic credit (% of GDP) in Indonesia in 2009 and the Domestic credit (% of GDP) in Suriname in 2011?
Provide a succinct answer. 4. What is the difference between the Domestic credit (% of GDP) in Kuwait in 2009 and the Domestic credit (% of GDP) in Paraguay in 2011?
Ensure brevity in your answer.  40.18. What is the difference between the Domestic credit (% of GDP) in Kuwait in 2009 and the Domestic credit (% of GDP) in Suriname in 2011?
Your answer should be very brief. 55.46. What is the difference between the Domestic credit (% of GDP) of Paraguay in 2009 and the Domestic credit (% of GDP) of Suriname in 2011?
Provide a succinct answer. 6.63. What is the difference between the Domestic credit (% of GDP) in Indonesia in 2009 and the Domestic credit (% of GDP) in Kuwait in 2012?
Offer a very short reply. -28.08. What is the difference between the Domestic credit (% of GDP) in Indonesia in 2009 and the Domestic credit (% of GDP) in Paraguay in 2012?
Make the answer very short. -15.02. What is the difference between the Domestic credit (% of GDP) in Indonesia in 2009 and the Domestic credit (% of GDP) in Suriname in 2012?
Your answer should be compact. 3.46. What is the difference between the Domestic credit (% of GDP) of Kuwait in 2009 and the Domestic credit (% of GDP) of Paraguay in 2012?
Give a very brief answer. 36.44. What is the difference between the Domestic credit (% of GDP) in Kuwait in 2009 and the Domestic credit (% of GDP) in Suriname in 2012?
Make the answer very short. 54.92. What is the difference between the Domestic credit (% of GDP) in Paraguay in 2009 and the Domestic credit (% of GDP) in Suriname in 2012?
Your answer should be compact. 6.09. What is the difference between the Domestic credit (% of GDP) in Indonesia in 2010 and the Domestic credit (% of GDP) in Kuwait in 2011?
Make the answer very short. -33.55. What is the difference between the Domestic credit (% of GDP) in Indonesia in 2010 and the Domestic credit (% of GDP) in Paraguay in 2011?
Your answer should be compact. -11.68. What is the difference between the Domestic credit (% of GDP) in Indonesia in 2010 and the Domestic credit (% of GDP) in Suriname in 2011?
Offer a terse response. 3.6. What is the difference between the Domestic credit (% of GDP) of Kuwait in 2010 and the Domestic credit (% of GDP) of Paraguay in 2011?
Provide a succinct answer. 35.7. What is the difference between the Domestic credit (% of GDP) in Kuwait in 2010 and the Domestic credit (% of GDP) in Suriname in 2011?
Give a very brief answer. 50.98. What is the difference between the Domestic credit (% of GDP) of Paraguay in 2010 and the Domestic credit (% of GDP) of Suriname in 2011?
Your answer should be compact. 10.91. What is the difference between the Domestic credit (% of GDP) of Indonesia in 2010 and the Domestic credit (% of GDP) of Kuwait in 2012?
Provide a succinct answer. -28.49. What is the difference between the Domestic credit (% of GDP) of Indonesia in 2010 and the Domestic credit (% of GDP) of Paraguay in 2012?
Your answer should be compact. -15.42. What is the difference between the Domestic credit (% of GDP) of Indonesia in 2010 and the Domestic credit (% of GDP) of Suriname in 2012?
Provide a succinct answer. 3.06. What is the difference between the Domestic credit (% of GDP) of Kuwait in 2010 and the Domestic credit (% of GDP) of Paraguay in 2012?
Make the answer very short. 31.96. What is the difference between the Domestic credit (% of GDP) in Kuwait in 2010 and the Domestic credit (% of GDP) in Suriname in 2012?
Your answer should be compact. 50.44. What is the difference between the Domestic credit (% of GDP) in Paraguay in 2010 and the Domestic credit (% of GDP) in Suriname in 2012?
Offer a terse response. 10.38. What is the difference between the Domestic credit (% of GDP) in Indonesia in 2011 and the Domestic credit (% of GDP) in Kuwait in 2012?
Make the answer very short. -25.66. What is the difference between the Domestic credit (% of GDP) of Indonesia in 2011 and the Domestic credit (% of GDP) of Paraguay in 2012?
Provide a short and direct response. -12.59. What is the difference between the Domestic credit (% of GDP) in Indonesia in 2011 and the Domestic credit (% of GDP) in Suriname in 2012?
Your answer should be compact. 5.89. What is the difference between the Domestic credit (% of GDP) of Kuwait in 2011 and the Domestic credit (% of GDP) of Paraguay in 2012?
Offer a very short reply. 18.13. What is the difference between the Domestic credit (% of GDP) in Kuwait in 2011 and the Domestic credit (% of GDP) in Suriname in 2012?
Your answer should be compact. 36.61. What is the difference between the Domestic credit (% of GDP) in Paraguay in 2011 and the Domestic credit (% of GDP) in Suriname in 2012?
Provide a succinct answer. 14.74. What is the average Domestic credit (% of GDP) of Indonesia per year?
Your answer should be very brief. 27.68. What is the average Domestic credit (% of GDP) of Kuwait per year?
Your answer should be compact. 61. What is the average Domestic credit (% of GDP) in Paraguay per year?
Make the answer very short. 27.38. What is the average Domestic credit (% of GDP) in Suriname per year?
Your answer should be very brief. 22.29. In the year 2005, what is the difference between the Domestic credit (% of GDP) of Indonesia and Domestic credit (% of GDP) of Kuwait?
Keep it short and to the point. -24.51. In the year 2005, what is the difference between the Domestic credit (% of GDP) in Indonesia and Domestic credit (% of GDP) in Paraguay?
Your response must be concise. 11.33. In the year 2005, what is the difference between the Domestic credit (% of GDP) in Indonesia and Domestic credit (% of GDP) in Suriname?
Keep it short and to the point. 7.11. In the year 2005, what is the difference between the Domestic credit (% of GDP) of Kuwait and Domestic credit (% of GDP) of Paraguay?
Provide a succinct answer. 35.84. In the year 2005, what is the difference between the Domestic credit (% of GDP) of Kuwait and Domestic credit (% of GDP) of Suriname?
Offer a terse response. 31.62. In the year 2005, what is the difference between the Domestic credit (% of GDP) of Paraguay and Domestic credit (% of GDP) of Suriname?
Your answer should be very brief. -4.22. In the year 2006, what is the difference between the Domestic credit (% of GDP) of Indonesia and Domestic credit (% of GDP) of Kuwait?
Keep it short and to the point. -25.35. In the year 2006, what is the difference between the Domestic credit (% of GDP) of Indonesia and Domestic credit (% of GDP) of Paraguay?
Your answer should be very brief. 9.89. In the year 2006, what is the difference between the Domestic credit (% of GDP) in Indonesia and Domestic credit (% of GDP) in Suriname?
Offer a very short reply. 7.12. In the year 2006, what is the difference between the Domestic credit (% of GDP) of Kuwait and Domestic credit (% of GDP) of Paraguay?
Offer a terse response. 35.23. In the year 2006, what is the difference between the Domestic credit (% of GDP) of Kuwait and Domestic credit (% of GDP) of Suriname?
Ensure brevity in your answer.  32.46. In the year 2006, what is the difference between the Domestic credit (% of GDP) in Paraguay and Domestic credit (% of GDP) in Suriname?
Offer a very short reply. -2.77. In the year 2007, what is the difference between the Domestic credit (% of GDP) in Indonesia and Domestic credit (% of GDP) in Kuwait?
Offer a terse response. -34.12. In the year 2007, what is the difference between the Domestic credit (% of GDP) of Indonesia and Domestic credit (% of GDP) of Paraguay?
Provide a short and direct response. 7.7. In the year 2007, what is the difference between the Domestic credit (% of GDP) of Indonesia and Domestic credit (% of GDP) of Suriname?
Make the answer very short. 4.1. In the year 2007, what is the difference between the Domestic credit (% of GDP) in Kuwait and Domestic credit (% of GDP) in Paraguay?
Make the answer very short. 41.82. In the year 2007, what is the difference between the Domestic credit (% of GDP) of Kuwait and Domestic credit (% of GDP) of Suriname?
Keep it short and to the point. 38.22. In the year 2007, what is the difference between the Domestic credit (% of GDP) in Paraguay and Domestic credit (% of GDP) in Suriname?
Keep it short and to the point. -3.6. In the year 2008, what is the difference between the Domestic credit (% of GDP) of Indonesia and Domestic credit (% of GDP) of Kuwait?
Your response must be concise. -30.71. In the year 2008, what is the difference between the Domestic credit (% of GDP) in Indonesia and Domestic credit (% of GDP) in Paraguay?
Offer a very short reply. 1.6. In the year 2008, what is the difference between the Domestic credit (% of GDP) in Indonesia and Domestic credit (% of GDP) in Suriname?
Ensure brevity in your answer.  2.69. In the year 2008, what is the difference between the Domestic credit (% of GDP) in Kuwait and Domestic credit (% of GDP) in Paraguay?
Make the answer very short. 32.31. In the year 2008, what is the difference between the Domestic credit (% of GDP) in Kuwait and Domestic credit (% of GDP) in Suriname?
Provide a succinct answer. 33.4. In the year 2008, what is the difference between the Domestic credit (% of GDP) of Paraguay and Domestic credit (% of GDP) of Suriname?
Your response must be concise. 1.09. In the year 2009, what is the difference between the Domestic credit (% of GDP) in Indonesia and Domestic credit (% of GDP) in Kuwait?
Your answer should be very brief. -51.46. In the year 2009, what is the difference between the Domestic credit (% of GDP) in Indonesia and Domestic credit (% of GDP) in Paraguay?
Offer a very short reply. -2.63. In the year 2009, what is the difference between the Domestic credit (% of GDP) in Indonesia and Domestic credit (% of GDP) in Suriname?
Make the answer very short. 3.25. In the year 2009, what is the difference between the Domestic credit (% of GDP) of Kuwait and Domestic credit (% of GDP) of Paraguay?
Give a very brief answer. 48.83. In the year 2009, what is the difference between the Domestic credit (% of GDP) in Kuwait and Domestic credit (% of GDP) in Suriname?
Your answer should be very brief. 54.71. In the year 2009, what is the difference between the Domestic credit (% of GDP) in Paraguay and Domestic credit (% of GDP) in Suriname?
Your answer should be very brief. 5.88. In the year 2010, what is the difference between the Domestic credit (% of GDP) in Indonesia and Domestic credit (% of GDP) in Kuwait?
Keep it short and to the point. -47.39. In the year 2010, what is the difference between the Domestic credit (% of GDP) in Indonesia and Domestic credit (% of GDP) in Paraguay?
Offer a very short reply. -7.32. In the year 2010, what is the difference between the Domestic credit (% of GDP) in Indonesia and Domestic credit (% of GDP) in Suriname?
Ensure brevity in your answer.  3.23. In the year 2010, what is the difference between the Domestic credit (% of GDP) in Kuwait and Domestic credit (% of GDP) in Paraguay?
Make the answer very short. 40.07. In the year 2010, what is the difference between the Domestic credit (% of GDP) in Kuwait and Domestic credit (% of GDP) in Suriname?
Make the answer very short. 50.62. In the year 2010, what is the difference between the Domestic credit (% of GDP) of Paraguay and Domestic credit (% of GDP) of Suriname?
Offer a terse response. 10.55. In the year 2011, what is the difference between the Domestic credit (% of GDP) in Indonesia and Domestic credit (% of GDP) in Kuwait?
Offer a terse response. -30.72. In the year 2011, what is the difference between the Domestic credit (% of GDP) of Indonesia and Domestic credit (% of GDP) of Paraguay?
Offer a terse response. -8.86. In the year 2011, what is the difference between the Domestic credit (% of GDP) in Indonesia and Domestic credit (% of GDP) in Suriname?
Your answer should be compact. 6.42. In the year 2011, what is the difference between the Domestic credit (% of GDP) of Kuwait and Domestic credit (% of GDP) of Paraguay?
Your answer should be very brief. 21.87. In the year 2011, what is the difference between the Domestic credit (% of GDP) in Kuwait and Domestic credit (% of GDP) in Suriname?
Offer a very short reply. 37.15. In the year 2011, what is the difference between the Domestic credit (% of GDP) in Paraguay and Domestic credit (% of GDP) in Suriname?
Give a very brief answer. 15.28. In the year 2012, what is the difference between the Domestic credit (% of GDP) of Indonesia and Domestic credit (% of GDP) of Kuwait?
Provide a short and direct response. -22.31. In the year 2012, what is the difference between the Domestic credit (% of GDP) of Indonesia and Domestic credit (% of GDP) of Paraguay?
Ensure brevity in your answer.  -9.24. In the year 2012, what is the difference between the Domestic credit (% of GDP) of Indonesia and Domestic credit (% of GDP) of Suriname?
Offer a very short reply. 9.24. In the year 2012, what is the difference between the Domestic credit (% of GDP) of Kuwait and Domestic credit (% of GDP) of Paraguay?
Provide a succinct answer. 13.07. In the year 2012, what is the difference between the Domestic credit (% of GDP) in Kuwait and Domestic credit (% of GDP) in Suriname?
Make the answer very short. 31.55. In the year 2012, what is the difference between the Domestic credit (% of GDP) in Paraguay and Domestic credit (% of GDP) in Suriname?
Your answer should be very brief. 18.48. What is the ratio of the Domestic credit (% of GDP) of Indonesia in 2005 to that in 2006?
Make the answer very short. 1.07. What is the ratio of the Domestic credit (% of GDP) in Kuwait in 2005 to that in 2006?
Keep it short and to the point. 1.02. What is the ratio of the Domestic credit (% of GDP) of Paraguay in 2005 to that in 2006?
Offer a very short reply. 1.03. What is the ratio of the Domestic credit (% of GDP) in Suriname in 2005 to that in 2006?
Offer a very short reply. 1.1. What is the ratio of the Domestic credit (% of GDP) of Indonesia in 2005 to that in 2007?
Keep it short and to the point. 1.04. What is the ratio of the Domestic credit (% of GDP) in Kuwait in 2005 to that in 2007?
Offer a very short reply. 0.85. What is the ratio of the Domestic credit (% of GDP) of Paraguay in 2005 to that in 2007?
Ensure brevity in your answer.  0.85. What is the ratio of the Domestic credit (% of GDP) of Suriname in 2005 to that in 2007?
Your answer should be very brief. 0.9. What is the ratio of the Domestic credit (% of GDP) in Kuwait in 2005 to that in 2008?
Make the answer very short. 0.89. What is the ratio of the Domestic credit (% of GDP) of Paraguay in 2005 to that in 2008?
Provide a succinct answer. 0.6. What is the ratio of the Domestic credit (% of GDP) of Suriname in 2005 to that in 2008?
Make the answer very short. 0.81. What is the ratio of the Domestic credit (% of GDP) in Indonesia in 2005 to that in 2009?
Offer a terse response. 0.96. What is the ratio of the Domestic credit (% of GDP) of Kuwait in 2005 to that in 2009?
Keep it short and to the point. 0.64. What is the ratio of the Domestic credit (% of GDP) in Paraguay in 2005 to that in 2009?
Offer a very short reply. 0.5. What is the ratio of the Domestic credit (% of GDP) of Suriname in 2005 to that in 2009?
Keep it short and to the point. 0.79. What is the ratio of the Domestic credit (% of GDP) of Indonesia in 2005 to that in 2010?
Your response must be concise. 0.97. What is the ratio of the Domestic credit (% of GDP) in Kuwait in 2005 to that in 2010?
Give a very brief answer. 0.68. What is the ratio of the Domestic credit (% of GDP) of Paraguay in 2005 to that in 2010?
Make the answer very short. 0.44. What is the ratio of the Domestic credit (% of GDP) in Suriname in 2005 to that in 2010?
Provide a short and direct response. 0.8. What is the ratio of the Domestic credit (% of GDP) in Indonesia in 2005 to that in 2011?
Provide a succinct answer. 0.88. What is the ratio of the Domestic credit (% of GDP) of Kuwait in 2005 to that in 2011?
Keep it short and to the point. 0.84. What is the ratio of the Domestic credit (% of GDP) of Paraguay in 2005 to that in 2011?
Offer a very short reply. 0.39. What is the ratio of the Domestic credit (% of GDP) in Suriname in 2005 to that in 2011?
Make the answer very short. 0.82. What is the ratio of the Domestic credit (% of GDP) in Indonesia in 2005 to that in 2012?
Offer a very short reply. 0.79. What is the ratio of the Domestic credit (% of GDP) in Kuwait in 2005 to that in 2012?
Keep it short and to the point. 0.91. What is the ratio of the Domestic credit (% of GDP) in Paraguay in 2005 to that in 2012?
Provide a short and direct response. 0.35. What is the ratio of the Domestic credit (% of GDP) of Suriname in 2005 to that in 2012?
Provide a succinct answer. 0.8. What is the ratio of the Domestic credit (% of GDP) of Indonesia in 2006 to that in 2007?
Your response must be concise. 0.97. What is the ratio of the Domestic credit (% of GDP) of Kuwait in 2006 to that in 2007?
Your answer should be compact. 0.84. What is the ratio of the Domestic credit (% of GDP) in Paraguay in 2006 to that in 2007?
Your response must be concise. 0.83. What is the ratio of the Domestic credit (% of GDP) in Suriname in 2006 to that in 2007?
Provide a short and direct response. 0.82. What is the ratio of the Domestic credit (% of GDP) in Indonesia in 2006 to that in 2008?
Offer a very short reply. 0.93. What is the ratio of the Domestic credit (% of GDP) in Kuwait in 2006 to that in 2008?
Offer a very short reply. 0.87. What is the ratio of the Domestic credit (% of GDP) in Paraguay in 2006 to that in 2008?
Make the answer very short. 0.59. What is the ratio of the Domestic credit (% of GDP) of Suriname in 2006 to that in 2008?
Your answer should be compact. 0.73. What is the ratio of the Domestic credit (% of GDP) of Indonesia in 2006 to that in 2009?
Your response must be concise. 0.89. What is the ratio of the Domestic credit (% of GDP) of Kuwait in 2006 to that in 2009?
Your response must be concise. 0.63. What is the ratio of the Domestic credit (% of GDP) of Paraguay in 2006 to that in 2009?
Offer a terse response. 0.49. What is the ratio of the Domestic credit (% of GDP) in Suriname in 2006 to that in 2009?
Provide a succinct answer. 0.72. What is the ratio of the Domestic credit (% of GDP) of Indonesia in 2006 to that in 2010?
Offer a terse response. 0.9. What is the ratio of the Domestic credit (% of GDP) of Kuwait in 2006 to that in 2010?
Offer a terse response. 0.67. What is the ratio of the Domestic credit (% of GDP) of Paraguay in 2006 to that in 2010?
Offer a very short reply. 0.43. What is the ratio of the Domestic credit (% of GDP) in Suriname in 2006 to that in 2010?
Provide a succinct answer. 0.73. What is the ratio of the Domestic credit (% of GDP) of Indonesia in 2006 to that in 2011?
Provide a succinct answer. 0.82. What is the ratio of the Domestic credit (% of GDP) in Kuwait in 2006 to that in 2011?
Offer a terse response. 0.82. What is the ratio of the Domestic credit (% of GDP) in Paraguay in 2006 to that in 2011?
Ensure brevity in your answer.  0.38. What is the ratio of the Domestic credit (% of GDP) of Suriname in 2006 to that in 2011?
Your answer should be compact. 0.74. What is the ratio of the Domestic credit (% of GDP) of Indonesia in 2006 to that in 2012?
Ensure brevity in your answer.  0.74. What is the ratio of the Domestic credit (% of GDP) in Kuwait in 2006 to that in 2012?
Give a very brief answer. 0.9. What is the ratio of the Domestic credit (% of GDP) in Paraguay in 2006 to that in 2012?
Ensure brevity in your answer.  0.34. What is the ratio of the Domestic credit (% of GDP) in Suriname in 2006 to that in 2012?
Your answer should be compact. 0.72. What is the ratio of the Domestic credit (% of GDP) in Indonesia in 2007 to that in 2008?
Ensure brevity in your answer.  0.96. What is the ratio of the Domestic credit (% of GDP) of Kuwait in 2007 to that in 2008?
Offer a terse response. 1.04. What is the ratio of the Domestic credit (% of GDP) of Paraguay in 2007 to that in 2008?
Provide a succinct answer. 0.71. What is the ratio of the Domestic credit (% of GDP) of Suriname in 2007 to that in 2008?
Provide a short and direct response. 0.9. What is the ratio of the Domestic credit (% of GDP) of Indonesia in 2007 to that in 2009?
Provide a succinct answer. 0.92. What is the ratio of the Domestic credit (% of GDP) in Kuwait in 2007 to that in 2009?
Make the answer very short. 0.75. What is the ratio of the Domestic credit (% of GDP) of Paraguay in 2007 to that in 2009?
Make the answer very short. 0.59. What is the ratio of the Domestic credit (% of GDP) of Suriname in 2007 to that in 2009?
Keep it short and to the point. 0.88. What is the ratio of the Domestic credit (% of GDP) in Indonesia in 2007 to that in 2010?
Provide a short and direct response. 0.93. What is the ratio of the Domestic credit (% of GDP) in Kuwait in 2007 to that in 2010?
Ensure brevity in your answer.  0.8. What is the ratio of the Domestic credit (% of GDP) of Paraguay in 2007 to that in 2010?
Provide a succinct answer. 0.51. What is the ratio of the Domestic credit (% of GDP) in Suriname in 2007 to that in 2010?
Provide a short and direct response. 0.89. What is the ratio of the Domestic credit (% of GDP) in Indonesia in 2007 to that in 2011?
Your answer should be compact. 0.85. What is the ratio of the Domestic credit (% of GDP) of Kuwait in 2007 to that in 2011?
Offer a terse response. 0.98. What is the ratio of the Domestic credit (% of GDP) in Paraguay in 2007 to that in 2011?
Your response must be concise. 0.46. What is the ratio of the Domestic credit (% of GDP) of Suriname in 2007 to that in 2011?
Your answer should be very brief. 0.9. What is the ratio of the Domestic credit (% of GDP) in Indonesia in 2007 to that in 2012?
Offer a terse response. 0.76. What is the ratio of the Domestic credit (% of GDP) of Kuwait in 2007 to that in 2012?
Make the answer very short. 1.07. What is the ratio of the Domestic credit (% of GDP) in Paraguay in 2007 to that in 2012?
Provide a short and direct response. 0.42. What is the ratio of the Domestic credit (% of GDP) in Suriname in 2007 to that in 2012?
Provide a succinct answer. 0.88. What is the ratio of the Domestic credit (% of GDP) of Indonesia in 2008 to that in 2009?
Provide a short and direct response. 0.96. What is the ratio of the Domestic credit (% of GDP) of Kuwait in 2008 to that in 2009?
Give a very brief answer. 0.72. What is the ratio of the Domestic credit (% of GDP) in Paraguay in 2008 to that in 2009?
Offer a very short reply. 0.82. What is the ratio of the Domestic credit (% of GDP) of Suriname in 2008 to that in 2009?
Offer a terse response. 0.98. What is the ratio of the Domestic credit (% of GDP) of Indonesia in 2008 to that in 2010?
Your response must be concise. 0.97. What is the ratio of the Domestic credit (% of GDP) in Kuwait in 2008 to that in 2010?
Your answer should be compact. 0.77. What is the ratio of the Domestic credit (% of GDP) in Paraguay in 2008 to that in 2010?
Your answer should be very brief. 0.72. What is the ratio of the Domestic credit (% of GDP) in Indonesia in 2008 to that in 2011?
Keep it short and to the point. 0.88. What is the ratio of the Domestic credit (% of GDP) in Kuwait in 2008 to that in 2011?
Your answer should be very brief. 0.94. What is the ratio of the Domestic credit (% of GDP) of Paraguay in 2008 to that in 2011?
Your answer should be compact. 0.64. What is the ratio of the Domestic credit (% of GDP) in Suriname in 2008 to that in 2011?
Your answer should be very brief. 1.01. What is the ratio of the Domestic credit (% of GDP) of Indonesia in 2008 to that in 2012?
Provide a succinct answer. 0.79. What is the ratio of the Domestic credit (% of GDP) of Kuwait in 2008 to that in 2012?
Provide a short and direct response. 1.03. What is the ratio of the Domestic credit (% of GDP) of Paraguay in 2008 to that in 2012?
Make the answer very short. 0.58. What is the ratio of the Domestic credit (% of GDP) of Suriname in 2008 to that in 2012?
Offer a terse response. 0.99. What is the ratio of the Domestic credit (% of GDP) of Indonesia in 2009 to that in 2010?
Ensure brevity in your answer.  1.01. What is the ratio of the Domestic credit (% of GDP) of Kuwait in 2009 to that in 2010?
Ensure brevity in your answer.  1.06. What is the ratio of the Domestic credit (% of GDP) in Paraguay in 2009 to that in 2010?
Keep it short and to the point. 0.88. What is the ratio of the Domestic credit (% of GDP) in Suriname in 2009 to that in 2010?
Keep it short and to the point. 1.02. What is the ratio of the Domestic credit (% of GDP) of Indonesia in 2009 to that in 2011?
Your answer should be very brief. 0.92. What is the ratio of the Domestic credit (% of GDP) of Kuwait in 2009 to that in 2011?
Your answer should be compact. 1.3. What is the ratio of the Domestic credit (% of GDP) of Paraguay in 2009 to that in 2011?
Offer a terse response. 0.78. What is the ratio of the Domestic credit (% of GDP) in Suriname in 2009 to that in 2011?
Offer a very short reply. 1.03. What is the ratio of the Domestic credit (% of GDP) of Indonesia in 2009 to that in 2012?
Give a very brief answer. 0.83. What is the ratio of the Domestic credit (% of GDP) of Kuwait in 2009 to that in 2012?
Give a very brief answer. 1.42. What is the ratio of the Domestic credit (% of GDP) in Paraguay in 2009 to that in 2012?
Offer a very short reply. 0.71. What is the ratio of the Domestic credit (% of GDP) of Suriname in 2009 to that in 2012?
Provide a short and direct response. 1.01. What is the ratio of the Domestic credit (% of GDP) in Indonesia in 2010 to that in 2011?
Ensure brevity in your answer.  0.91. What is the ratio of the Domestic credit (% of GDP) in Kuwait in 2010 to that in 2011?
Ensure brevity in your answer.  1.23. What is the ratio of the Domestic credit (% of GDP) of Paraguay in 2010 to that in 2011?
Offer a very short reply. 0.89. What is the ratio of the Domestic credit (% of GDP) in Suriname in 2010 to that in 2011?
Give a very brief answer. 1.02. What is the ratio of the Domestic credit (% of GDP) in Indonesia in 2010 to that in 2012?
Your answer should be very brief. 0.82. What is the ratio of the Domestic credit (% of GDP) in Kuwait in 2010 to that in 2012?
Your answer should be very brief. 1.34. What is the ratio of the Domestic credit (% of GDP) of Paraguay in 2010 to that in 2012?
Offer a very short reply. 0.81. What is the ratio of the Domestic credit (% of GDP) in Indonesia in 2011 to that in 2012?
Your answer should be compact. 0.9. What is the ratio of the Domestic credit (% of GDP) in Kuwait in 2011 to that in 2012?
Offer a very short reply. 1.09. What is the ratio of the Domestic credit (% of GDP) in Paraguay in 2011 to that in 2012?
Ensure brevity in your answer.  0.91. What is the ratio of the Domestic credit (% of GDP) of Suriname in 2011 to that in 2012?
Your answer should be very brief. 0.98. What is the difference between the highest and the second highest Domestic credit (% of GDP) in Indonesia?
Provide a short and direct response. 3.35. What is the difference between the highest and the second highest Domestic credit (% of GDP) of Kuwait?
Offer a terse response. 4.48. What is the difference between the highest and the second highest Domestic credit (% of GDP) of Paraguay?
Keep it short and to the point. 3.74. What is the difference between the highest and the second highest Domestic credit (% of GDP) of Suriname?
Your answer should be very brief. 0.21. What is the difference between the highest and the lowest Domestic credit (% of GDP) of Indonesia?
Your answer should be compact. 8.83. What is the difference between the highest and the lowest Domestic credit (% of GDP) of Kuwait?
Give a very brief answer. 29.17. What is the difference between the highest and the lowest Domestic credit (% of GDP) of Paraguay?
Ensure brevity in your answer.  27.96. What is the difference between the highest and the lowest Domestic credit (% of GDP) in Suriname?
Keep it short and to the point. 6.92. 